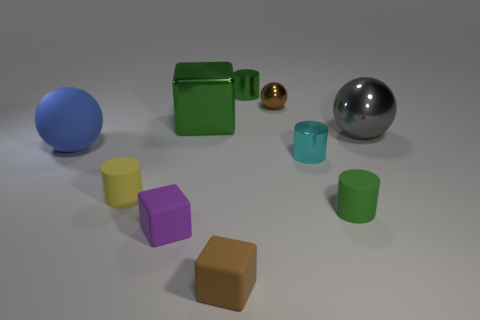Are there any tiny green cylinders behind the blue ball?
Your answer should be very brief. Yes. How big is the green cube?
Your answer should be very brief. Large. The blue rubber object that is the same shape as the big gray shiny thing is what size?
Offer a terse response. Large. How many shiny objects are left of the small green object to the right of the cyan metallic cylinder?
Offer a terse response. 4. Is the large blue sphere that is behind the yellow matte cylinder made of the same material as the green cylinder that is in front of the green shiny cylinder?
Provide a succinct answer. Yes. How many other tiny things have the same shape as the yellow thing?
Provide a succinct answer. 3. How many matte balls are the same color as the big metal ball?
Provide a succinct answer. 0. Do the big object left of the large cube and the gray object that is behind the yellow matte cylinder have the same shape?
Provide a short and direct response. Yes. How many cylinders are in front of the green metallic cylinder that is on the left side of the cylinder that is right of the small cyan cylinder?
Provide a short and direct response. 3. The cylinder in front of the yellow rubber cylinder that is on the left side of the cube behind the large blue thing is made of what material?
Your answer should be very brief. Rubber. 